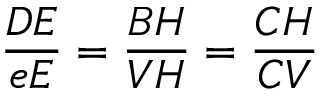<formula> <loc_0><loc_0><loc_500><loc_500>{ \frac { D E } { e E } } = { \frac { B H } { V H } } = { \frac { C H } { C V } }</formula> 